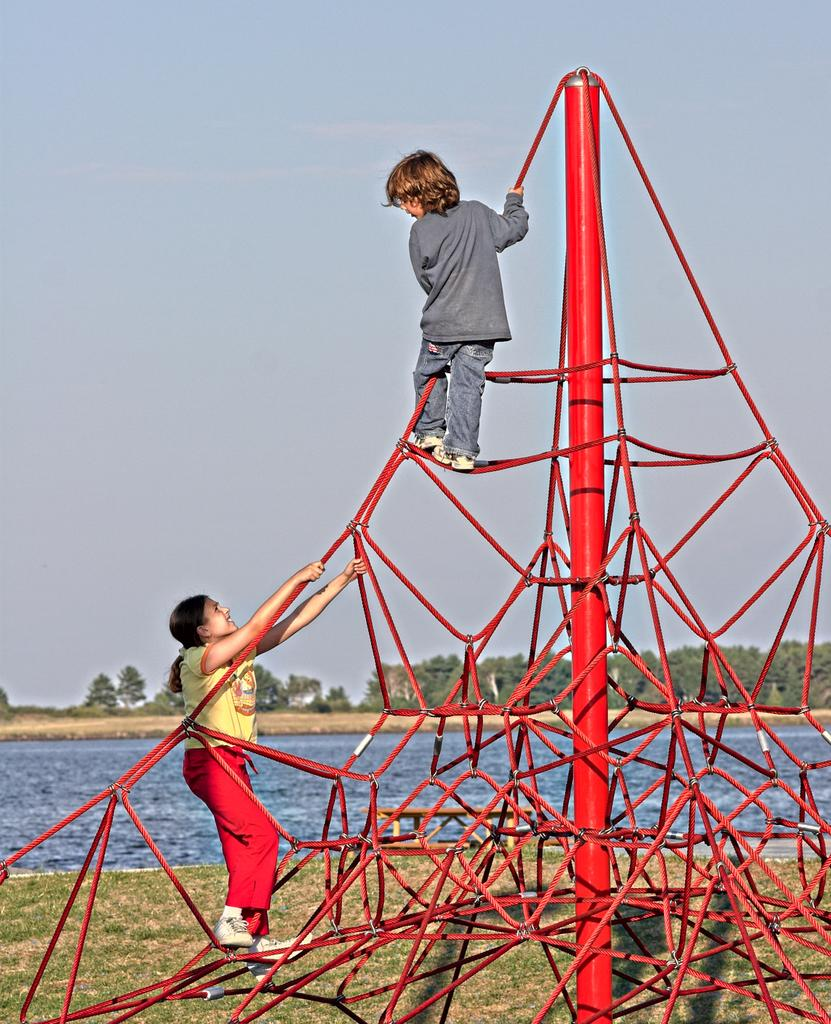What objects are present in the image related to climbing? There are ropes and a pole in the image. What are the kids doing in the image? Two kids are climbing the ropes. What can be seen in the background of the image? There is water and trees visible in the background. What type of jam is being spread on the net in the image? There is no jam or net present in the image; it features ropes, a pole, and two kids climbing the ropes. What request is being made by the person in the image? There is no person visible in the image, and therefore no request can be observed. 